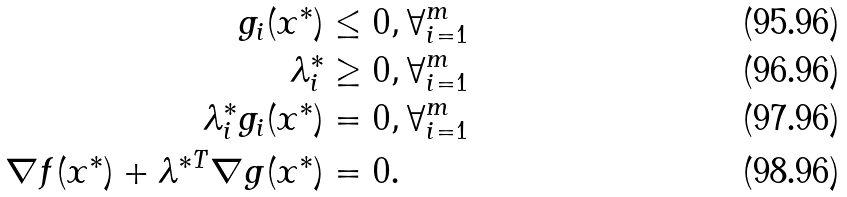<formula> <loc_0><loc_0><loc_500><loc_500>g _ { i } ( x ^ { * } ) & \leq 0 , \forall ^ { m } _ { i = 1 } \\ \lambda ^ { * } _ { i } & \geq 0 , \forall ^ { m } _ { i = 1 } \\ \lambda ^ { * } _ { i } g _ { i } ( x ^ { * } ) & = 0 , \forall ^ { m } _ { i = 1 } \\ \nabla f ( x ^ { * } ) + \lambda ^ { * T } \nabla g ( x ^ { * } ) & = 0 .</formula> 